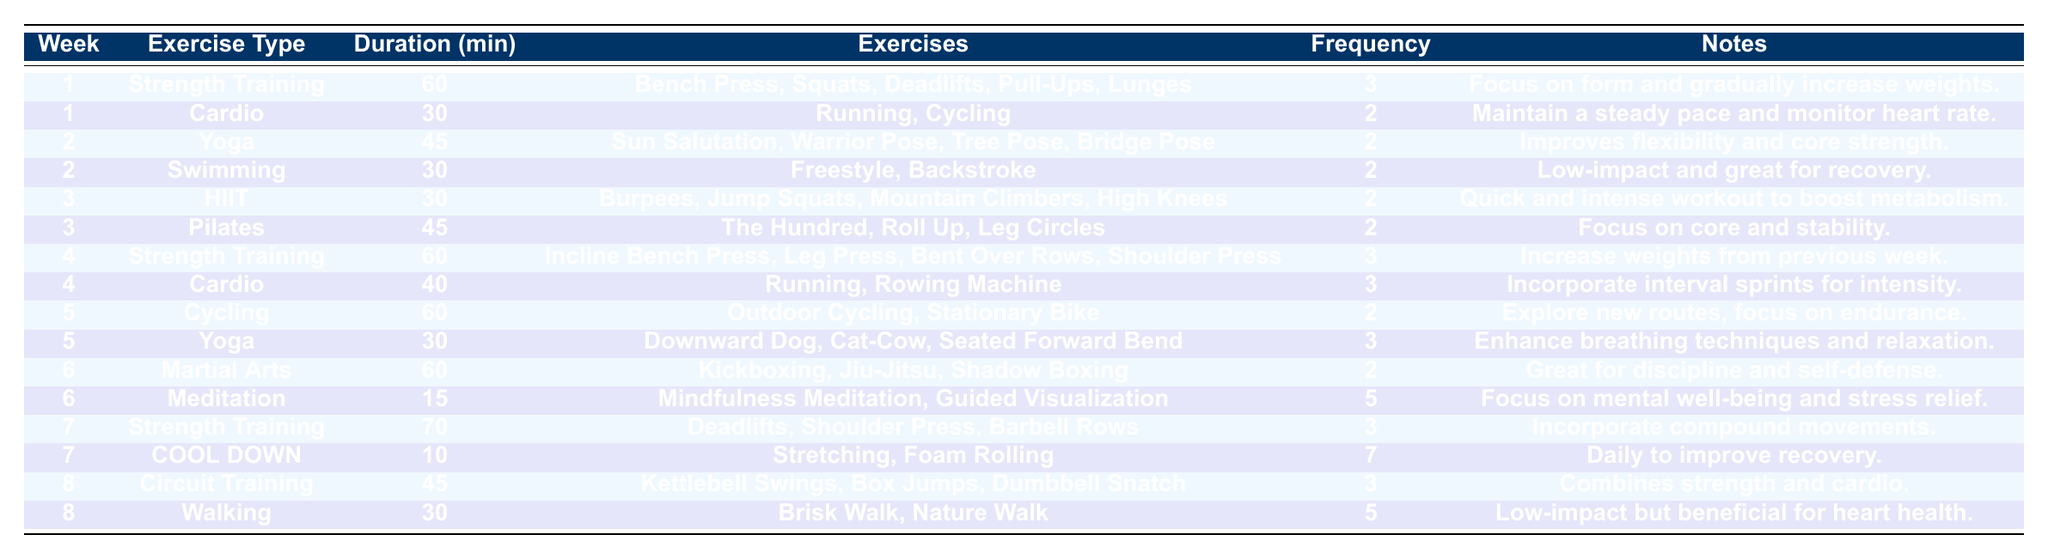What types of exercises are included in week 3? The table lists "HIIT" and "Pilates" as the exercise types for week 3.
Answer: HIIT and Pilates How many minutes of yoga are scheduled for week 5? The table shows that yoga is scheduled for 30 minutes in week 5.
Answer: 30 minutes What is the maximum duration for any exercise type in week 7? The longest duration in week 7 is for "Strength Training," which is 70 minutes.
Answer: 70 minutes Does week 6 include strength training exercises? The table confirms that week 6 does not include strength training, only martial arts and meditation.
Answer: No How many total minutes are dedicated to cardio workouts in week 4? The cardio in week 4 includes 40 minutes (running and rowing), which adds up to a total of 40 minutes.
Answer: 40 minutes In weeks 1 to 4, how many exercises focus on flexibility? In weeks 1 to 4, yoga (week 2) and the stretching exercises (week 7, as part of cool down) focus on flexibility. Thus, the total is 2 exercises.
Answer: 2 exercises What was the frequency of meditation in week 6 compared to HIIT in week 3? Meditation in week 6 has a frequency of 5, while HIIT in week 3 has a frequency of 2; thus, meditation has a higher frequency.
Answer: Higher frequency for meditation Which week focuses on "strength training" the most? Week 4 includes "Strength Training" for 60 minutes and is scheduled three times, which is the highest frequency for strength training.
Answer: Week 4 How many total types of exercises are in week 8? Week 8 includes "Circuit Training" and "Walking," so there are 2 types of exercises for that week.
Answer: 2 types What is the total duration of all exercise types for week 1? For week 1, strength training (60 minutes) and cardio (30 minutes) sum to 90 minutes.
Answer: 90 minutes Is there any difference in duration between strength training sessions in week 1 and week 4? Week 1 has 60 minutes and week 4 has 60 minutes for strength training, so there is no difference in duration.
Answer: No difference 